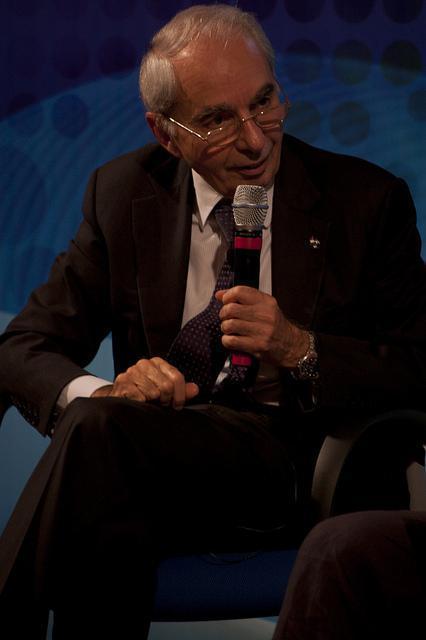How many people are there?
Give a very brief answer. 2. How many of the train carts have red around the windows?
Give a very brief answer. 0. 